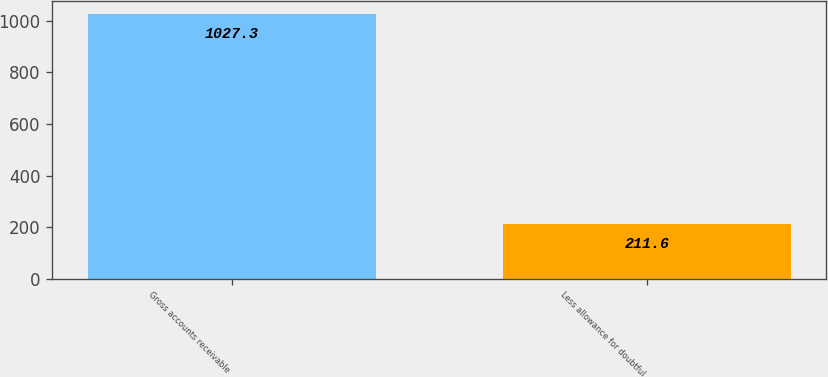<chart> <loc_0><loc_0><loc_500><loc_500><bar_chart><fcel>Gross accounts receivable<fcel>Less allowance for doubtful<nl><fcel>1027.3<fcel>211.6<nl></chart> 